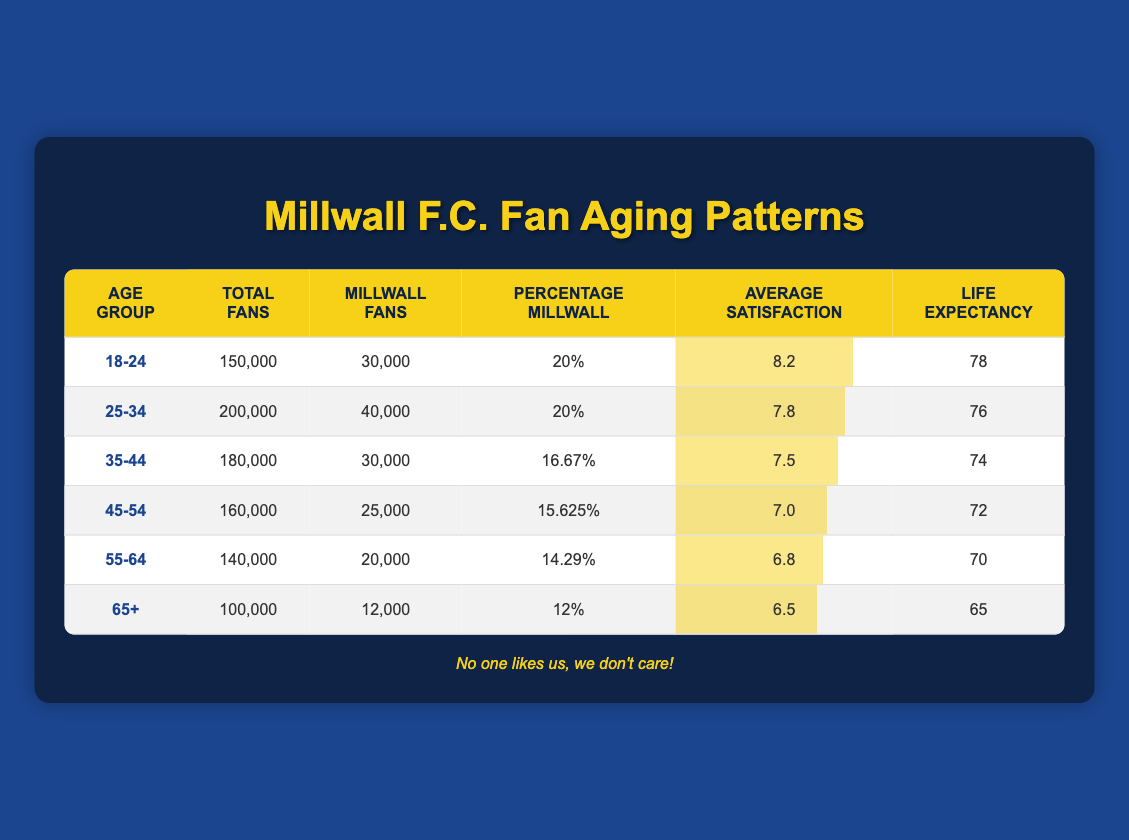What age group has the highest average satisfaction? The average satisfaction scores are 8.2 for the age group 18-24, 7.8 for 25-34, 7.5 for 35-44, 7.0 for 45-54, 6.8 for 55-64, and 6.5 for 65+. The highest score is 8.2, which belongs to the 18-24 age group.
Answer: 18-24 What is the total number of Millwall fans across all age groups? The number of Millwall fans in each age group is 30,000 (18-24) + 40,000 (25-34) + 30,000 (35-44) + 25,000 (45-54) + 20,000 (55-64) + 12,000 (65+) = 157,000.
Answer: 157,000 Is there an age group where the percentage of Millwall fans exceeds 20%? The ages 18-24 and 25-34 have 20% each, but all other groups have percentages lower than that, so there is no group exceeding 20%.
Answer: No What is the life expectancy of the age group 55-64? Referring to the table, the life expectancy listed for the age group 55-64 is 70 years.
Answer: 70 What is the difference in average satisfaction between the age groups 45-54 and 35-44? The average satisfaction for 45-54 is 7.0, and for 35-44, it's 7.5. The difference is calculated as 7.5 - 7.0 = 0.5.
Answer: 0.5 Which age group has the lowest total number of fans? The total number of fans for each group is: 18-24 (150,000), 25-34 (200,000), 35-44 (180,000), 45-54 (160,000), 55-64 (140,000), and 65+ (100,000). The age group 65+ has the lowest number of total fans at 100,000.
Answer: 65+ What percentage of fans in the 35-44 age group supports Millwall? For the 35-44 age group, the percentage of Millwall fans is listed as 16.67%. This value directly answers the question.
Answer: 16.67% If we compare 18-24 and 65+, how many more total fans are there in the 18-24 age group? The 18-24 age group has 150,000 total fans, and the 65+ age group has 100,000. The difference is 150,000 - 100,000 = 50,000 more fans in the 18-24 group.
Answer: 50,000 What is the average life expectancy of fans in the age groups 35-44 and 45-54 combined? The life expectancy for 35-44 is 74, and for 45-54 is 72. To find the average, we calculate (74 + 72) / 2 = 73.
Answer: 73 